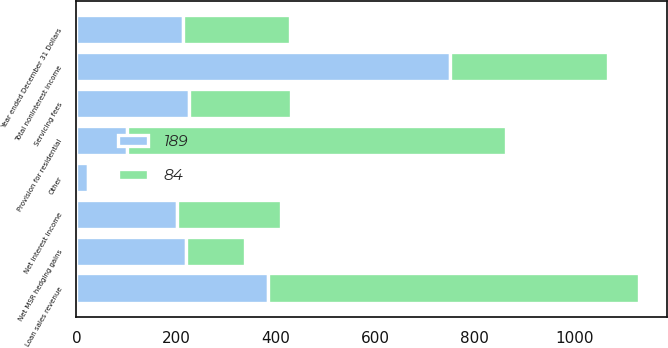Convert chart. <chart><loc_0><loc_0><loc_500><loc_500><stacked_bar_chart><ecel><fcel>Year ended December 31 Dollars<fcel>Net interest income<fcel>Servicing fees<fcel>Net MSR hedging gains<fcel>Provision for residential<fcel>Loan sales revenue<fcel>Other<fcel>Total noninterest income<nl><fcel>84<fcel>214.5<fcel>209<fcel>205<fcel>119<fcel>761<fcel>747<fcel>7<fcel>317<nl><fcel>189<fcel>214.5<fcel>201<fcel>226<fcel>220<fcel>102<fcel>384<fcel>23<fcel>751<nl></chart> 